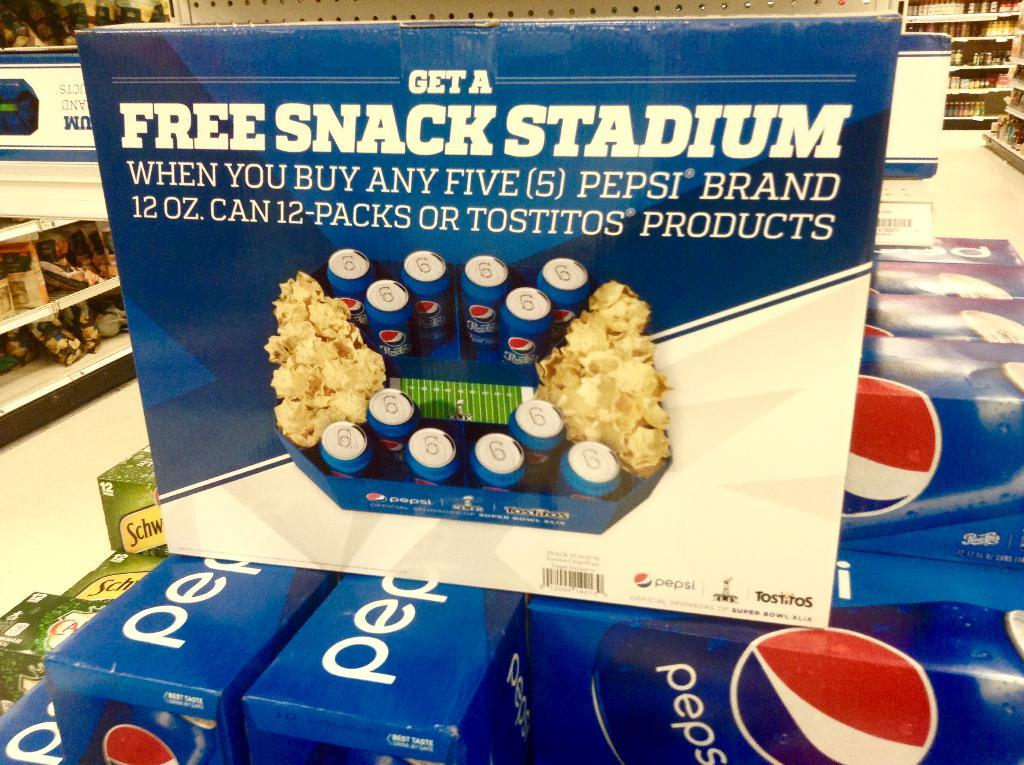What can be seen on the packets in the image? There is writing on the packets in the image. What brand or company might be represented by the logo in the image? The logo in the image might represent a brand or company. What type of items can be seen on the racks in the background of the image? There are racks with items in the background of the image, but the specific items cannot be determined from the provided facts. Can you tell me how many wires are connected to the logo in the image? There is no mention of wires in the provided facts, and therefore no such information can be determined from the image. 